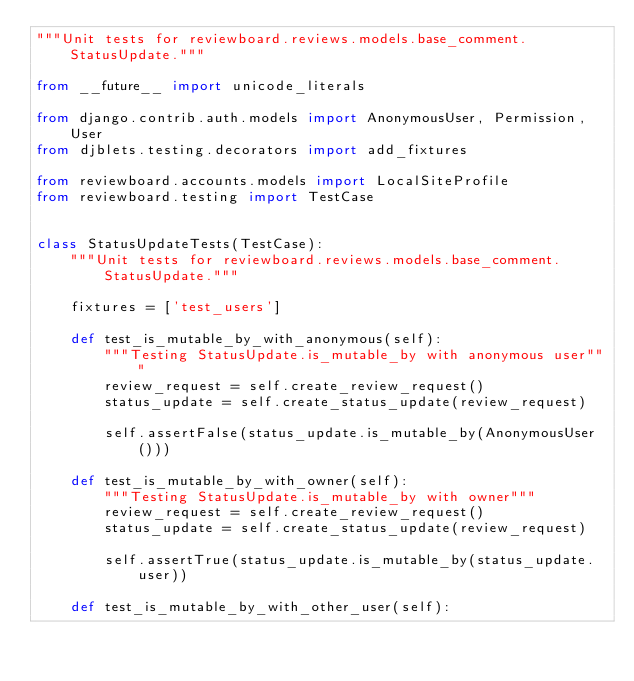<code> <loc_0><loc_0><loc_500><loc_500><_Python_>"""Unit tests for reviewboard.reviews.models.base_comment.StatusUpdate."""

from __future__ import unicode_literals

from django.contrib.auth.models import AnonymousUser, Permission, User
from djblets.testing.decorators import add_fixtures

from reviewboard.accounts.models import LocalSiteProfile
from reviewboard.testing import TestCase


class StatusUpdateTests(TestCase):
    """Unit tests for reviewboard.reviews.models.base_comment.StatusUpdate."""

    fixtures = ['test_users']

    def test_is_mutable_by_with_anonymous(self):
        """Testing StatusUpdate.is_mutable_by with anonymous user"""
        review_request = self.create_review_request()
        status_update = self.create_status_update(review_request)

        self.assertFalse(status_update.is_mutable_by(AnonymousUser()))

    def test_is_mutable_by_with_owner(self):
        """Testing StatusUpdate.is_mutable_by with owner"""
        review_request = self.create_review_request()
        status_update = self.create_status_update(review_request)

        self.assertTrue(status_update.is_mutable_by(status_update.user))

    def test_is_mutable_by_with_other_user(self):</code> 